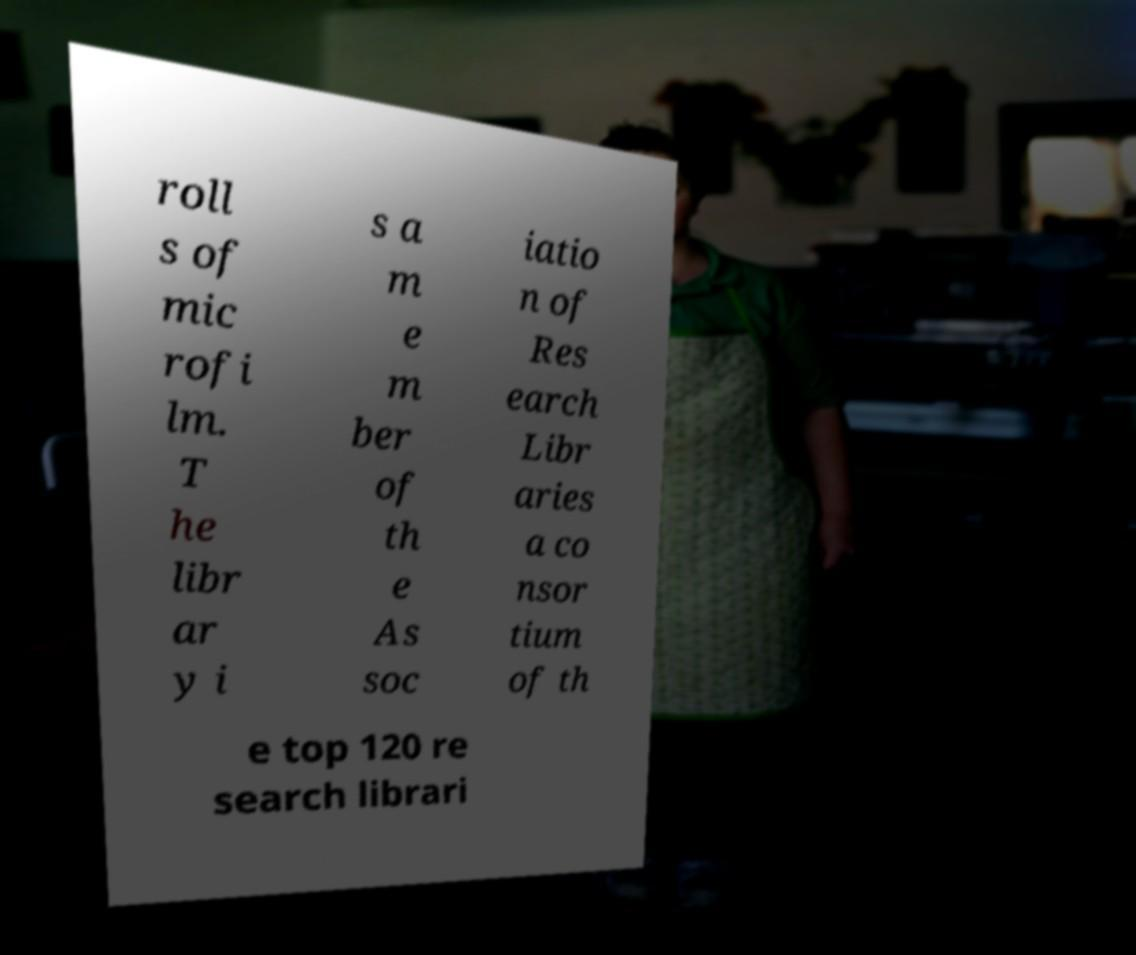There's text embedded in this image that I need extracted. Can you transcribe it verbatim? roll s of mic rofi lm. T he libr ar y i s a m e m ber of th e As soc iatio n of Res earch Libr aries a co nsor tium of th e top 120 re search librari 